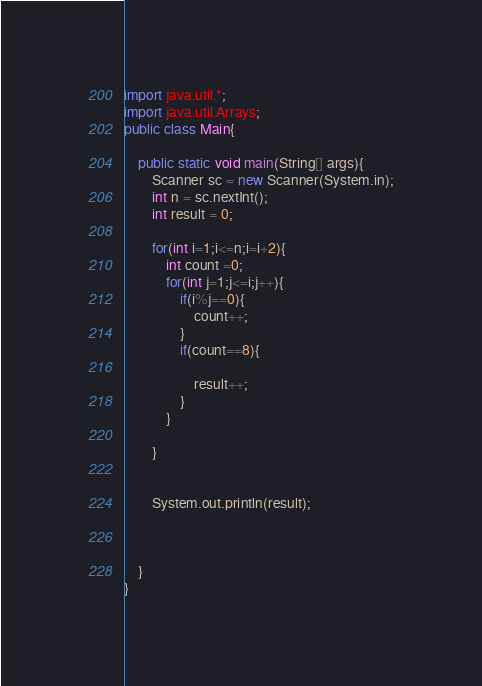<code> <loc_0><loc_0><loc_500><loc_500><_Java_>import java.util.*;
import java.util.Arrays;
public class Main{
    
    public static void main(String[] args){
        Scanner sc = new Scanner(System.in);
        int n = sc.nextInt();
        int result = 0;
       
        for(int i=1;i<=n;i=i+2){
            int count =0;
            for(int j=1;j<=i;j++){
                if(i%j==0){
                    count++;
                }
                if(count==8){
                    
                    result++;
                }
            }
            
        }


        System.out.println(result);
    


    }
}</code> 